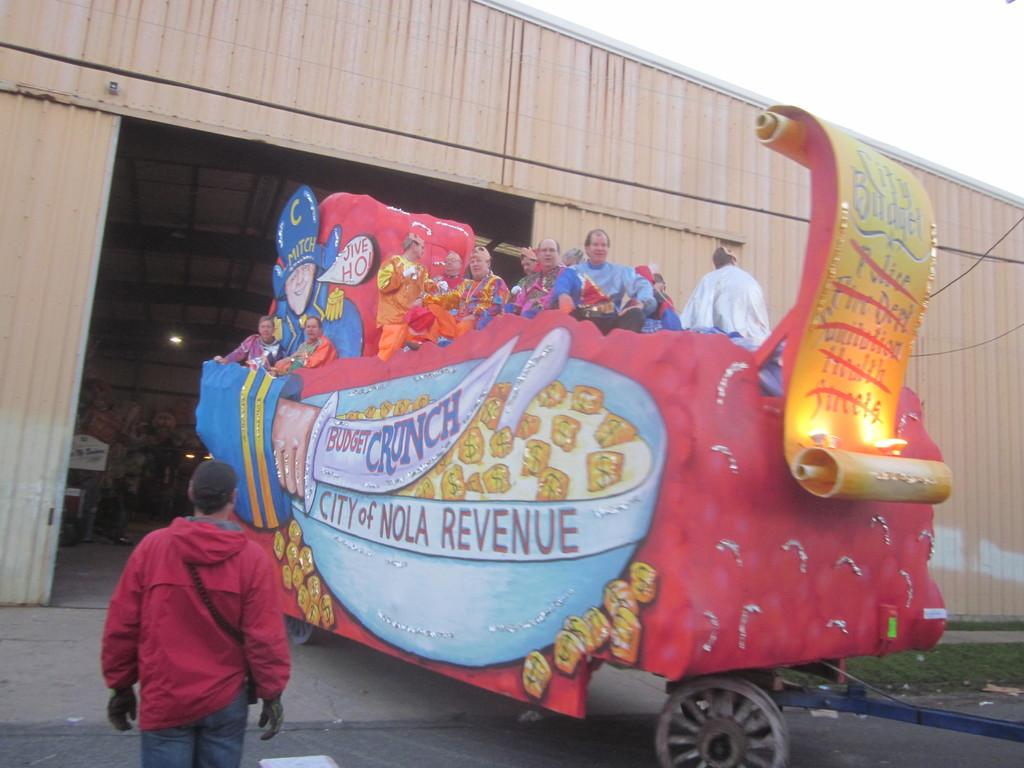What is the main subject of the image? There is a group of people in a decorated vehicle in the image. Are there any additional features in the image? Yes, there are lights, a shed, a person standing, and the sky visible in the background. What type of quince is being served during the recess in the image? There is no mention of quince or a recess in the image; it features a group of people in a decorated vehicle with additional elements. 